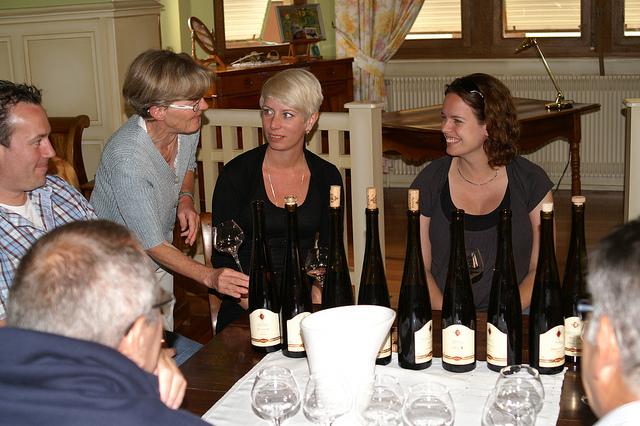What kind of beverage is on the table?
Be succinct. Wine. How many bottles are on the table?
Write a very short answer. 9. Have the bottles been opened?
Answer briefly. Yes. 